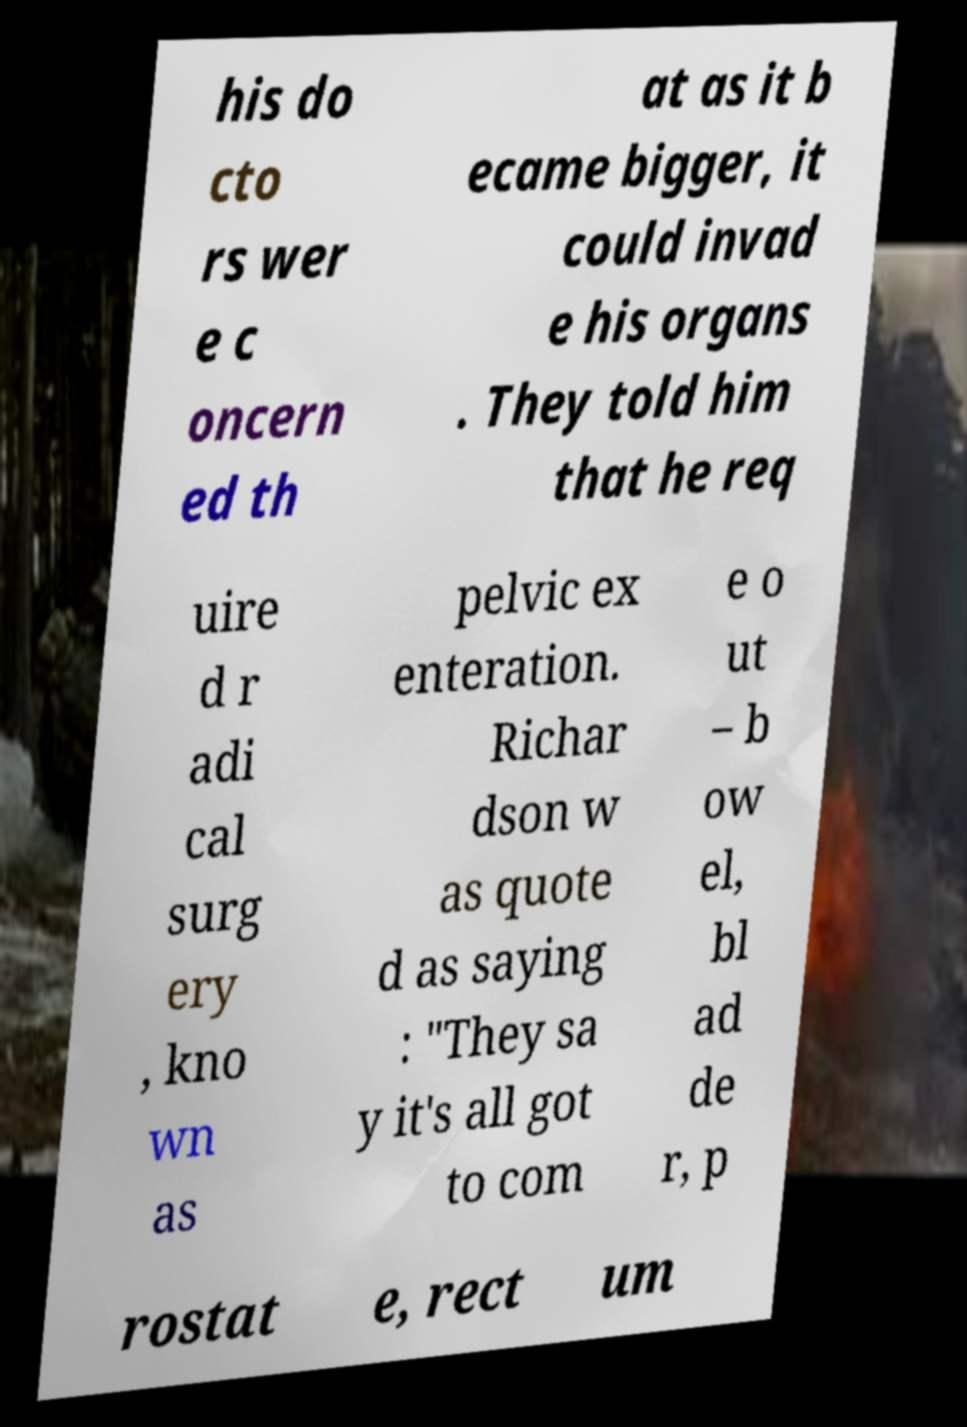I need the written content from this picture converted into text. Can you do that? his do cto rs wer e c oncern ed th at as it b ecame bigger, it could invad e his organs . They told him that he req uire d r adi cal surg ery , kno wn as pelvic ex enteration. Richar dson w as quote d as saying : "They sa y it's all got to com e o ut – b ow el, bl ad de r, p rostat e, rect um 